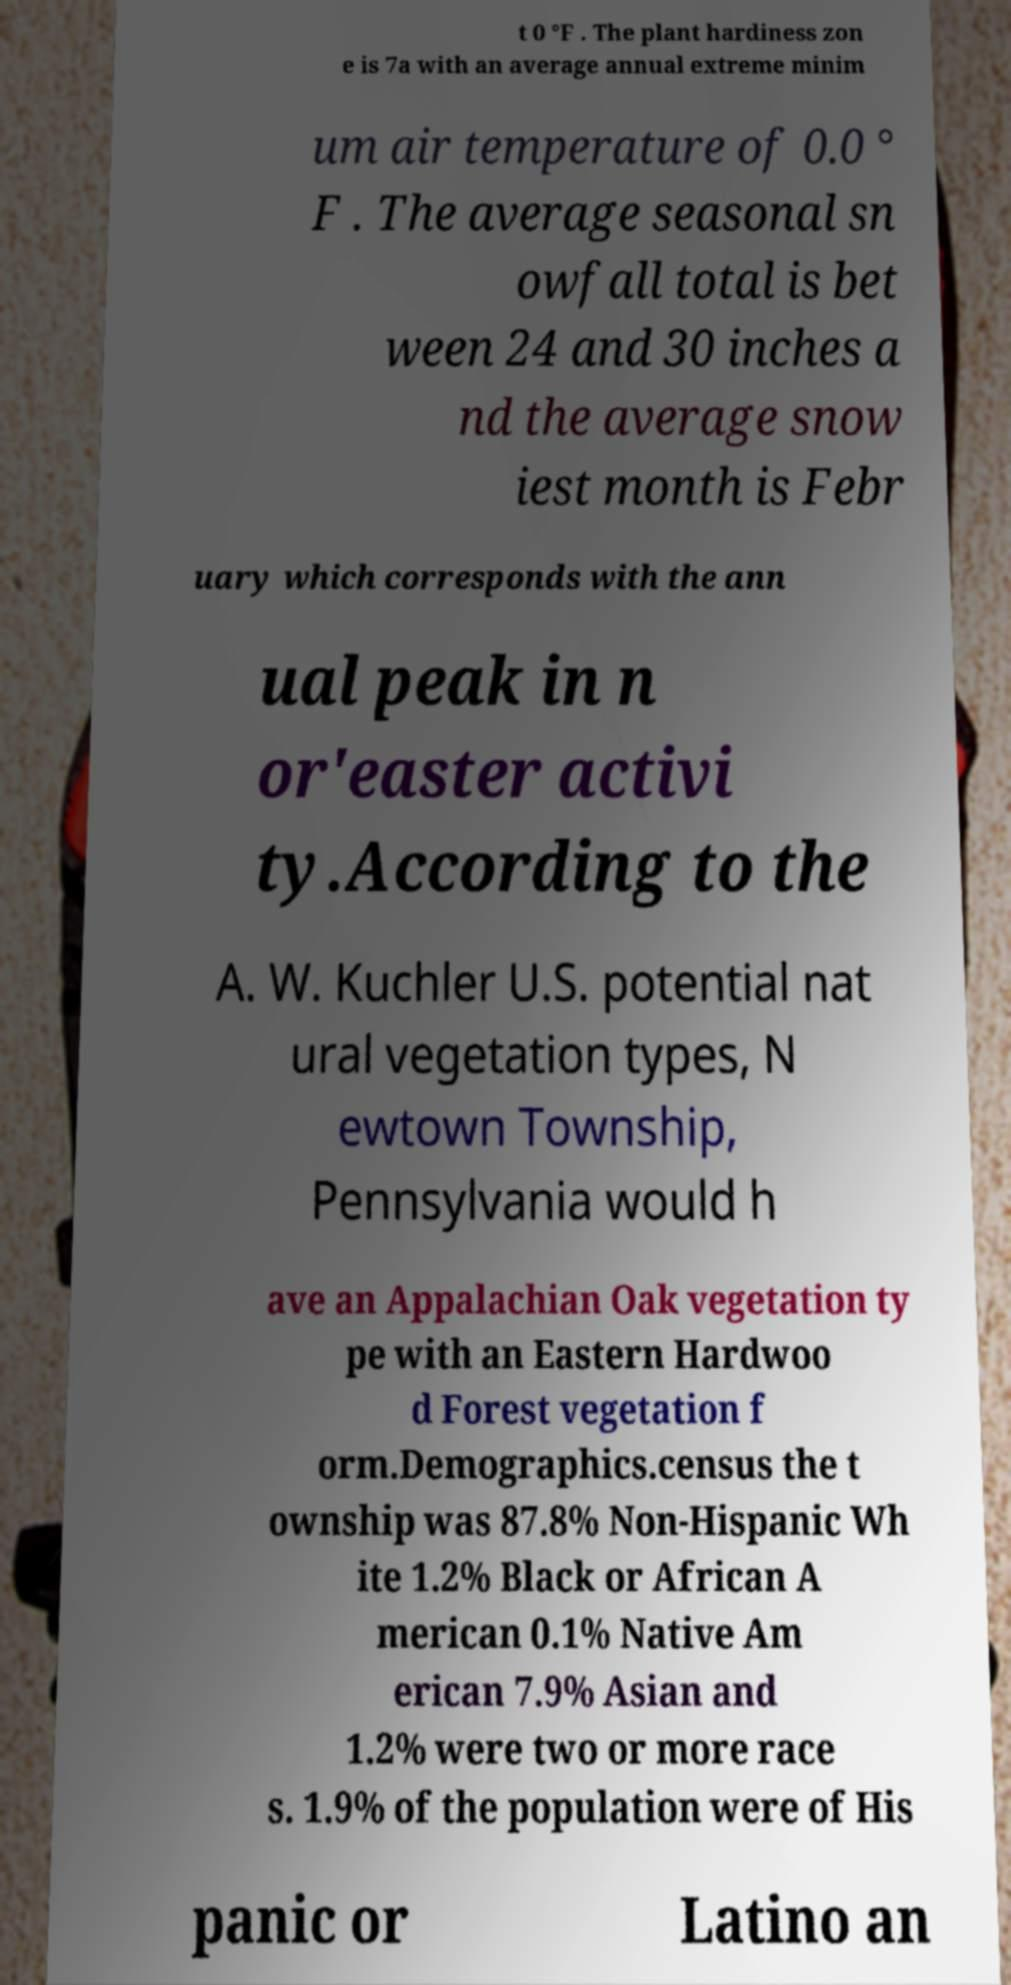For documentation purposes, I need the text within this image transcribed. Could you provide that? t 0 °F . The plant hardiness zon e is 7a with an average annual extreme minim um air temperature of 0.0 ° F . The average seasonal sn owfall total is bet ween 24 and 30 inches a nd the average snow iest month is Febr uary which corresponds with the ann ual peak in n or'easter activi ty.According to the A. W. Kuchler U.S. potential nat ural vegetation types, N ewtown Township, Pennsylvania would h ave an Appalachian Oak vegetation ty pe with an Eastern Hardwoo d Forest vegetation f orm.Demographics.census the t ownship was 87.8% Non-Hispanic Wh ite 1.2% Black or African A merican 0.1% Native Am erican 7.9% Asian and 1.2% were two or more race s. 1.9% of the population were of His panic or Latino an 